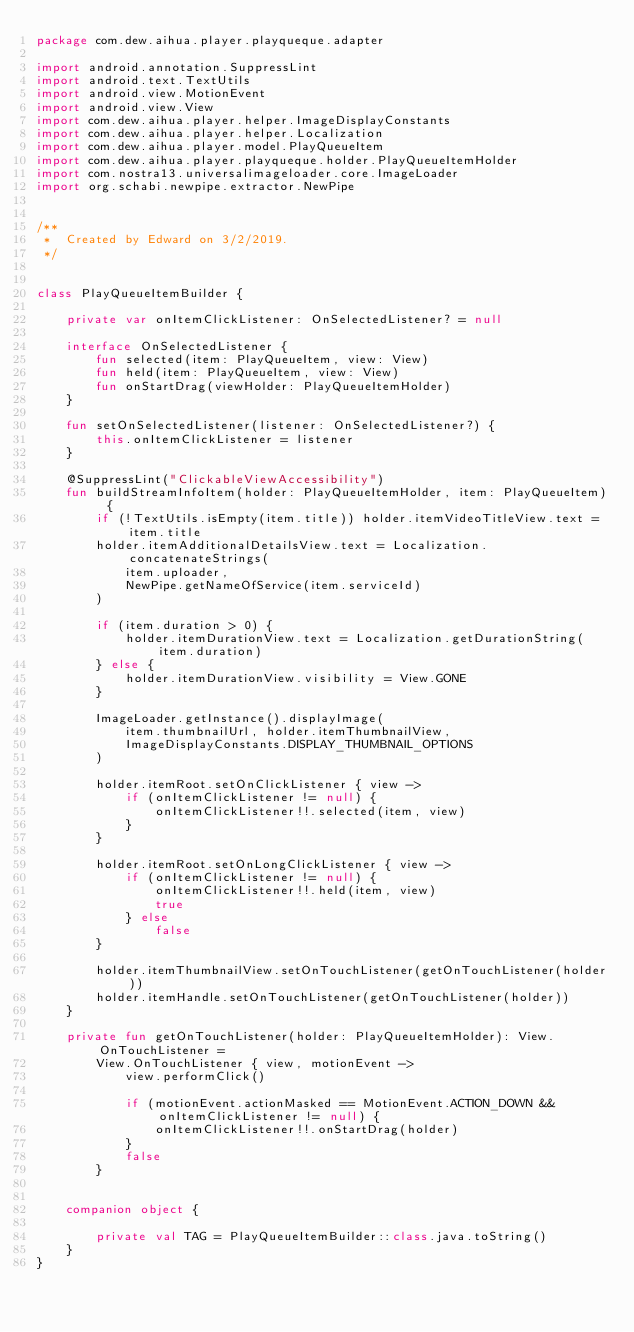<code> <loc_0><loc_0><loc_500><loc_500><_Kotlin_>package com.dew.aihua.player.playqueque.adapter

import android.annotation.SuppressLint
import android.text.TextUtils
import android.view.MotionEvent
import android.view.View
import com.dew.aihua.player.helper.ImageDisplayConstants
import com.dew.aihua.player.helper.Localization
import com.dew.aihua.player.model.PlayQueueItem
import com.dew.aihua.player.playqueque.holder.PlayQueueItemHolder
import com.nostra13.universalimageloader.core.ImageLoader
import org.schabi.newpipe.extractor.NewPipe


/**
 *  Created by Edward on 3/2/2019.
 */


class PlayQueueItemBuilder {

    private var onItemClickListener: OnSelectedListener? = null

    interface OnSelectedListener {
        fun selected(item: PlayQueueItem, view: View)
        fun held(item: PlayQueueItem, view: View)
        fun onStartDrag(viewHolder: PlayQueueItemHolder)
    }

    fun setOnSelectedListener(listener: OnSelectedListener?) {
        this.onItemClickListener = listener
    }

    @SuppressLint("ClickableViewAccessibility")
    fun buildStreamInfoItem(holder: PlayQueueItemHolder, item: PlayQueueItem) {
        if (!TextUtils.isEmpty(item.title)) holder.itemVideoTitleView.text = item.title
        holder.itemAdditionalDetailsView.text = Localization.concatenateStrings(
            item.uploader,
            NewPipe.getNameOfService(item.serviceId)
        )

        if (item.duration > 0) {
            holder.itemDurationView.text = Localization.getDurationString(item.duration)
        } else {
            holder.itemDurationView.visibility = View.GONE
        }

        ImageLoader.getInstance().displayImage(
            item.thumbnailUrl, holder.itemThumbnailView,
            ImageDisplayConstants.DISPLAY_THUMBNAIL_OPTIONS
        )

        holder.itemRoot.setOnClickListener { view ->
            if (onItemClickListener != null) {
                onItemClickListener!!.selected(item, view)
            }
        }

        holder.itemRoot.setOnLongClickListener { view ->
            if (onItemClickListener != null) {
                onItemClickListener!!.held(item, view)
                true
            } else
                false
        }

        holder.itemThumbnailView.setOnTouchListener(getOnTouchListener(holder))
        holder.itemHandle.setOnTouchListener(getOnTouchListener(holder))
    }

    private fun getOnTouchListener(holder: PlayQueueItemHolder): View.OnTouchListener =
        View.OnTouchListener { view, motionEvent ->
            view.performClick()

            if (motionEvent.actionMasked == MotionEvent.ACTION_DOWN && onItemClickListener != null) {
                onItemClickListener!!.onStartDrag(holder)
            }
            false
        }


    companion object {

        private val TAG = PlayQueueItemBuilder::class.java.toString()
    }
}
</code> 